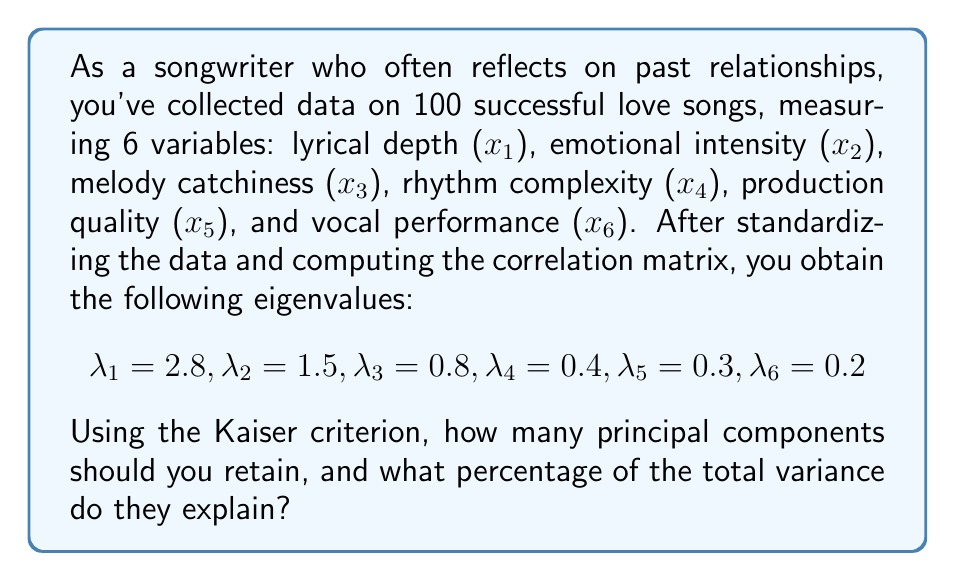Help me with this question. To solve this problem, we'll follow these steps:

1. Recall the Kaiser criterion: Retain principal components with eigenvalues greater than 1.

2. Identify the number of principal components to retain:
   $\lambda_1 = 2.8 > 1$
   $\lambda_2 = 1.5 > 1$
   $\lambda_3 = 0.8 < 1$
   
   Therefore, we retain 2 principal components.

3. Calculate the total variance:
   $$\text{Total Variance} = \sum_{i=1}^6 \lambda_i = 2.8 + 1.5 + 0.8 + 0.4 + 0.3 + 0.2 = 6$$

4. Calculate the variance explained by the retained components:
   $$\text{Variance Explained} = \lambda_1 + \lambda_2 = 2.8 + 1.5 = 4.3$$

5. Calculate the percentage of total variance explained:
   $$\text{Percentage} = \frac{\text{Variance Explained}}{\text{Total Variance}} \times 100\% = \frac{4.3}{6} \times 100\% \approx 71.67\%$$
Answer: Retain 2 principal components, explaining approximately 71.67% of the total variance. 